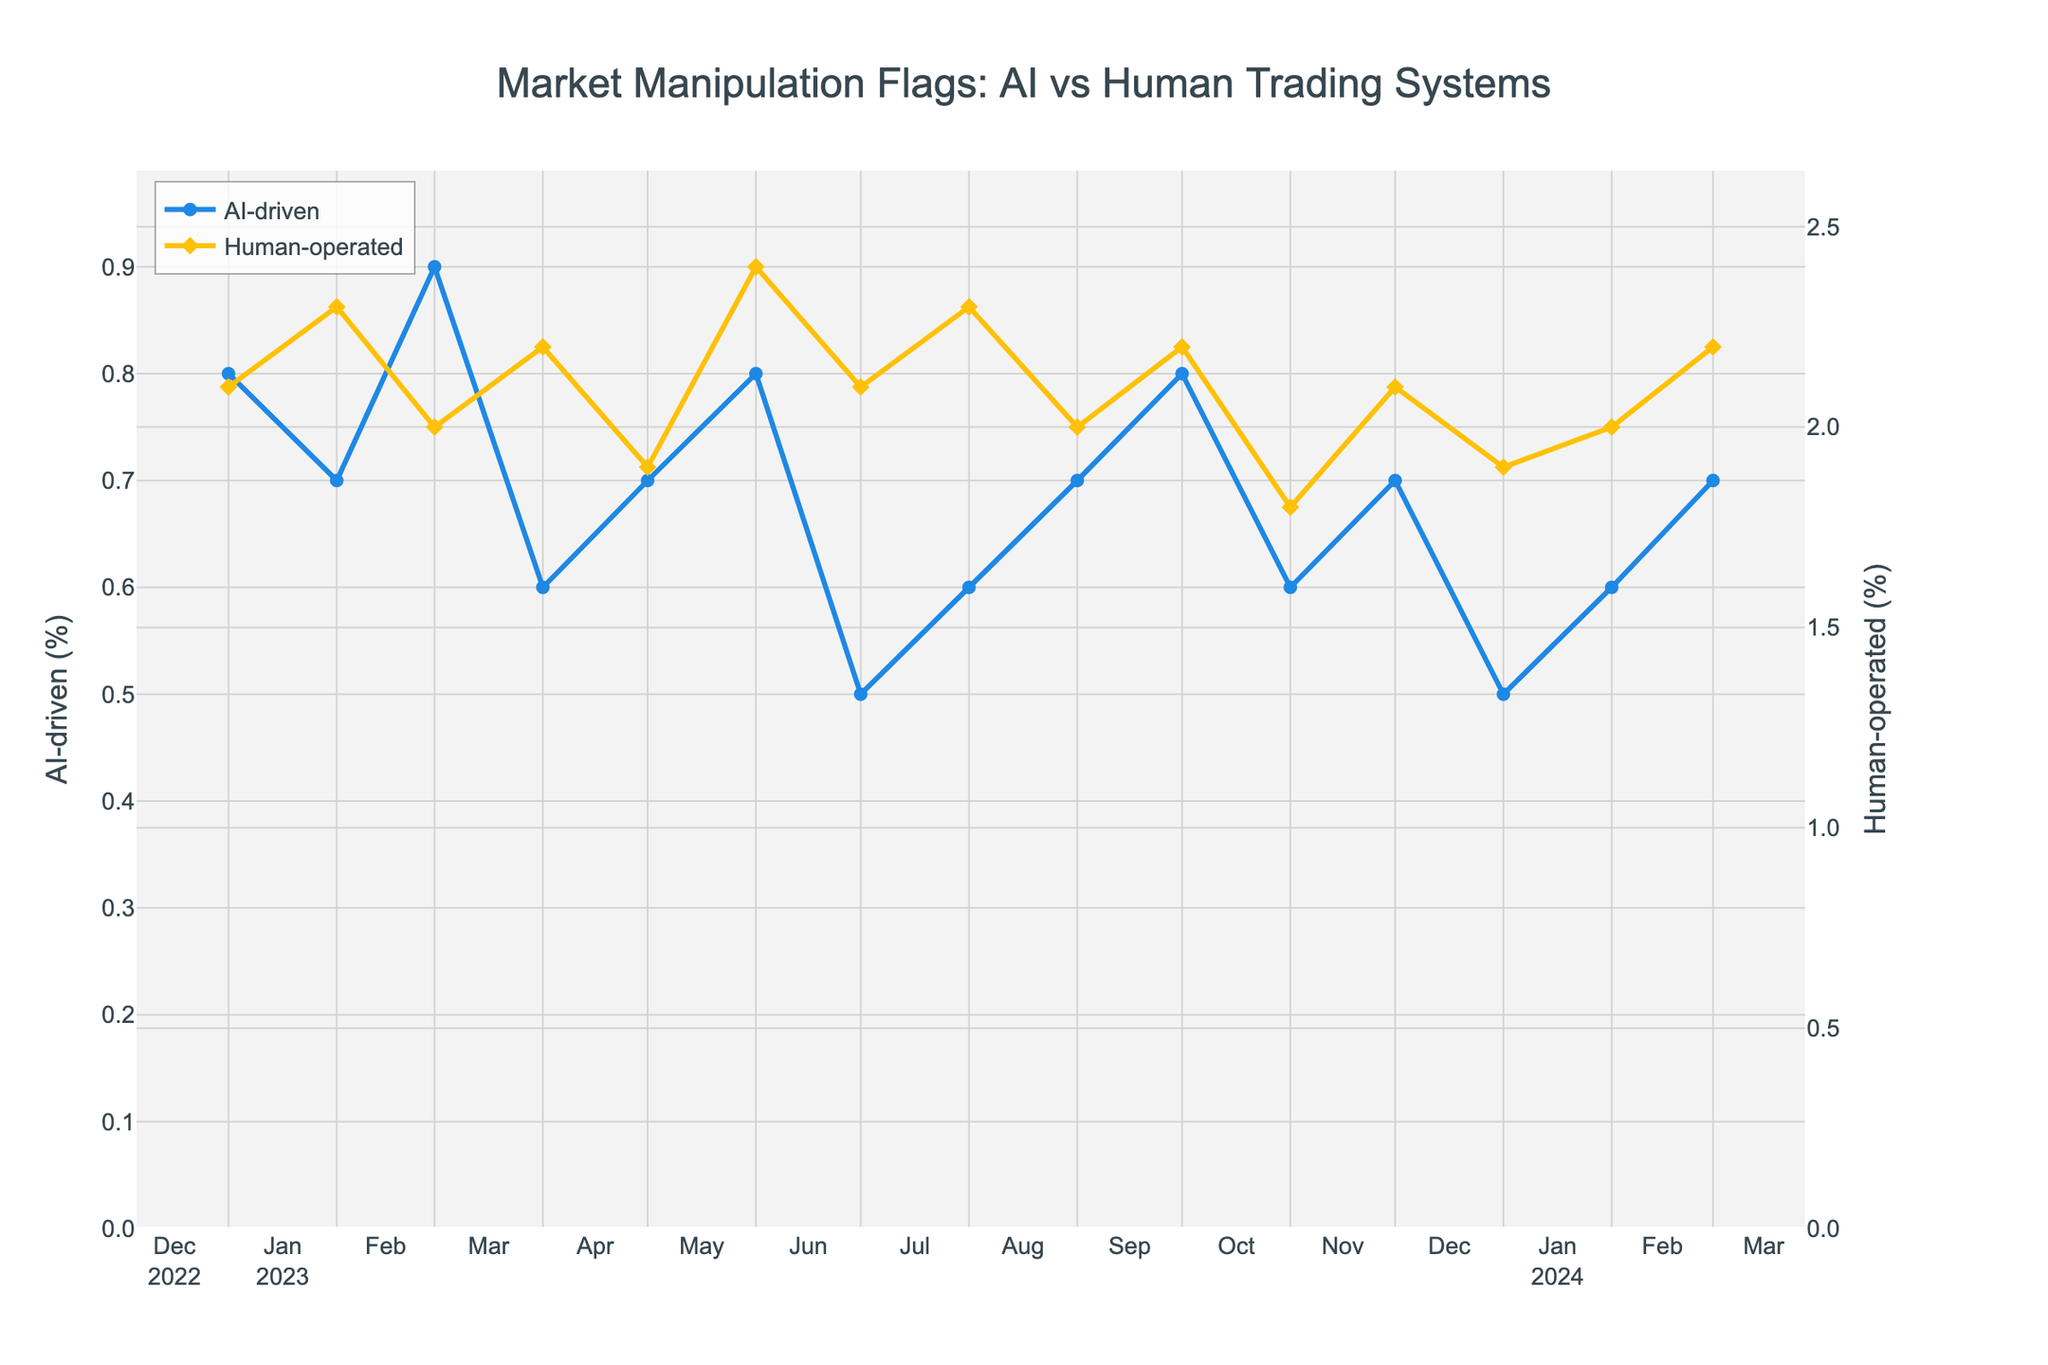What is the highest percentage of trades flagged for potential market manipulation in AI-driven trading systems? The figure shows the percentage of trades flagged for potential market manipulation in AI-driven trading systems. The highest percentage is represented by the highest point on the blue line (AI-driven). In the month of March 2023, the value is at its peak at 0.9%.
Answer: 0.9% Which month had the lowest percentage of trades flagged in both AI-driven and human-operated trading systems? To find the month with the lowest percentage in both systems, look for the lowest points on both lines. For AI-driven trading systems, the lowest value is 0.5% in July 2023 and January 2024. For human-operated trading systems, the lowest value is 1.8% in November 2023. November 2023 is the month where the lowest percentage occurs for human-operated.
Answer: November 2023 Compare the percentage of flagged trades between AI and human-operated trading systems in July 2023. How many times higher is the human-operated percentage than AI-driven? In July 2023, the AI-driven trading systems show 0.5% flagged trades, while human-operated systems show 2.1% flagged trades. To find how many times higher the human-operated percentage is: 2.1 / 0.5 = 4.2 times higher.
Answer: 4.2 times What is the average percentage of trades flagged for potential market manipulation in AI-driven trading systems over the entire period? To calculate the average, sum up all the percentages for AI-driven trading systems and divide by the number of months: (0.8 + 0.7 + 0.9 + 0.6 + 0.7 + 0.8 + 0.5 + 0.6 + 0.7 + 0.8 + 0.6 + 0.7 + 0.5 + 0.6 + 0.7)/15 = 0.68%
Answer: 0.68% In which months do both AI-driven and human-operated trading systems show the same percentage of flagged trades? Look for points where both lines intersect or are at the same level. The figure shows both percentages at 2.0% in February 2024
Answer: February 2024 What is the visual difference between the flags in AI-driven and human-operated trading systems in terms of markers and line color? The AI-driven trading system is represented by a blue line with circular markers, while the human-operated system is represented by an orange line with diamond-shaped markers.
Answer: Blue circles (AI-driven), Orange diamonds (Human-operated) Between May 2023 and October 2023, which trading system had more fluctuations in the percentage of flagged trades? To determine the trading system with more fluctuations, observe the changes in the lines between May 2023 and October 2023. The AI-driven system has slight fluctuations between 0.5% and 0.8%, while the human-operated system shows changes between 1.9% and 2.4%. Human-operated trading systems show more significant fluctuations.
Answer: Human-operated How does the trend of flagged trades change over time for AI-driven trading systems? Overall, the trend for AI-driven trading systems shows minor fluctuations around 0.5% to 0.9%, but there is no significant upward or downward trend over the months.
Answer: Minor fluctuations 